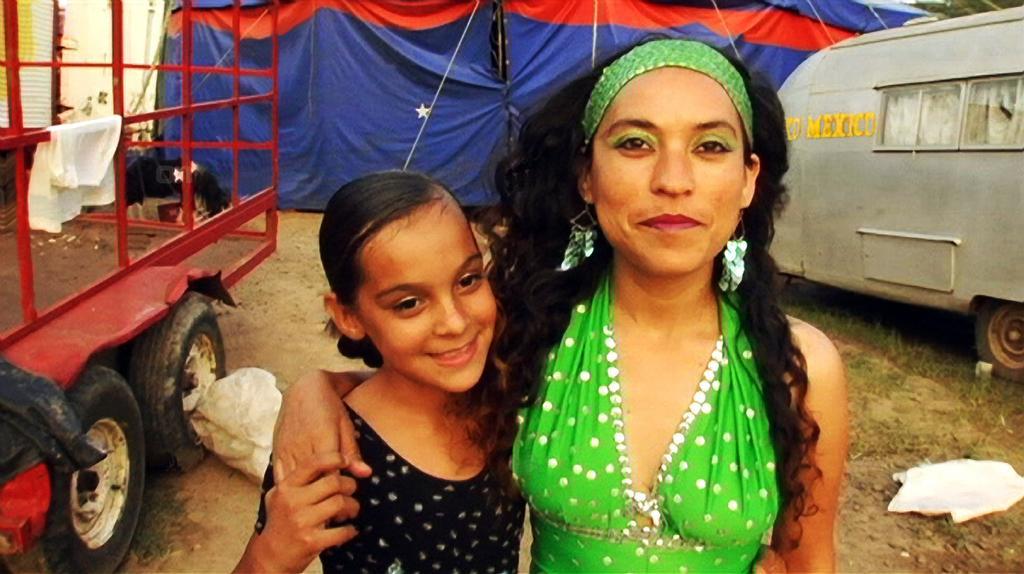Please provide a concise description of this image. In this image we can see a lady and a girl standing and smiling and we can see vehicles. In the background there is a tent. At the bottom there is grass. 